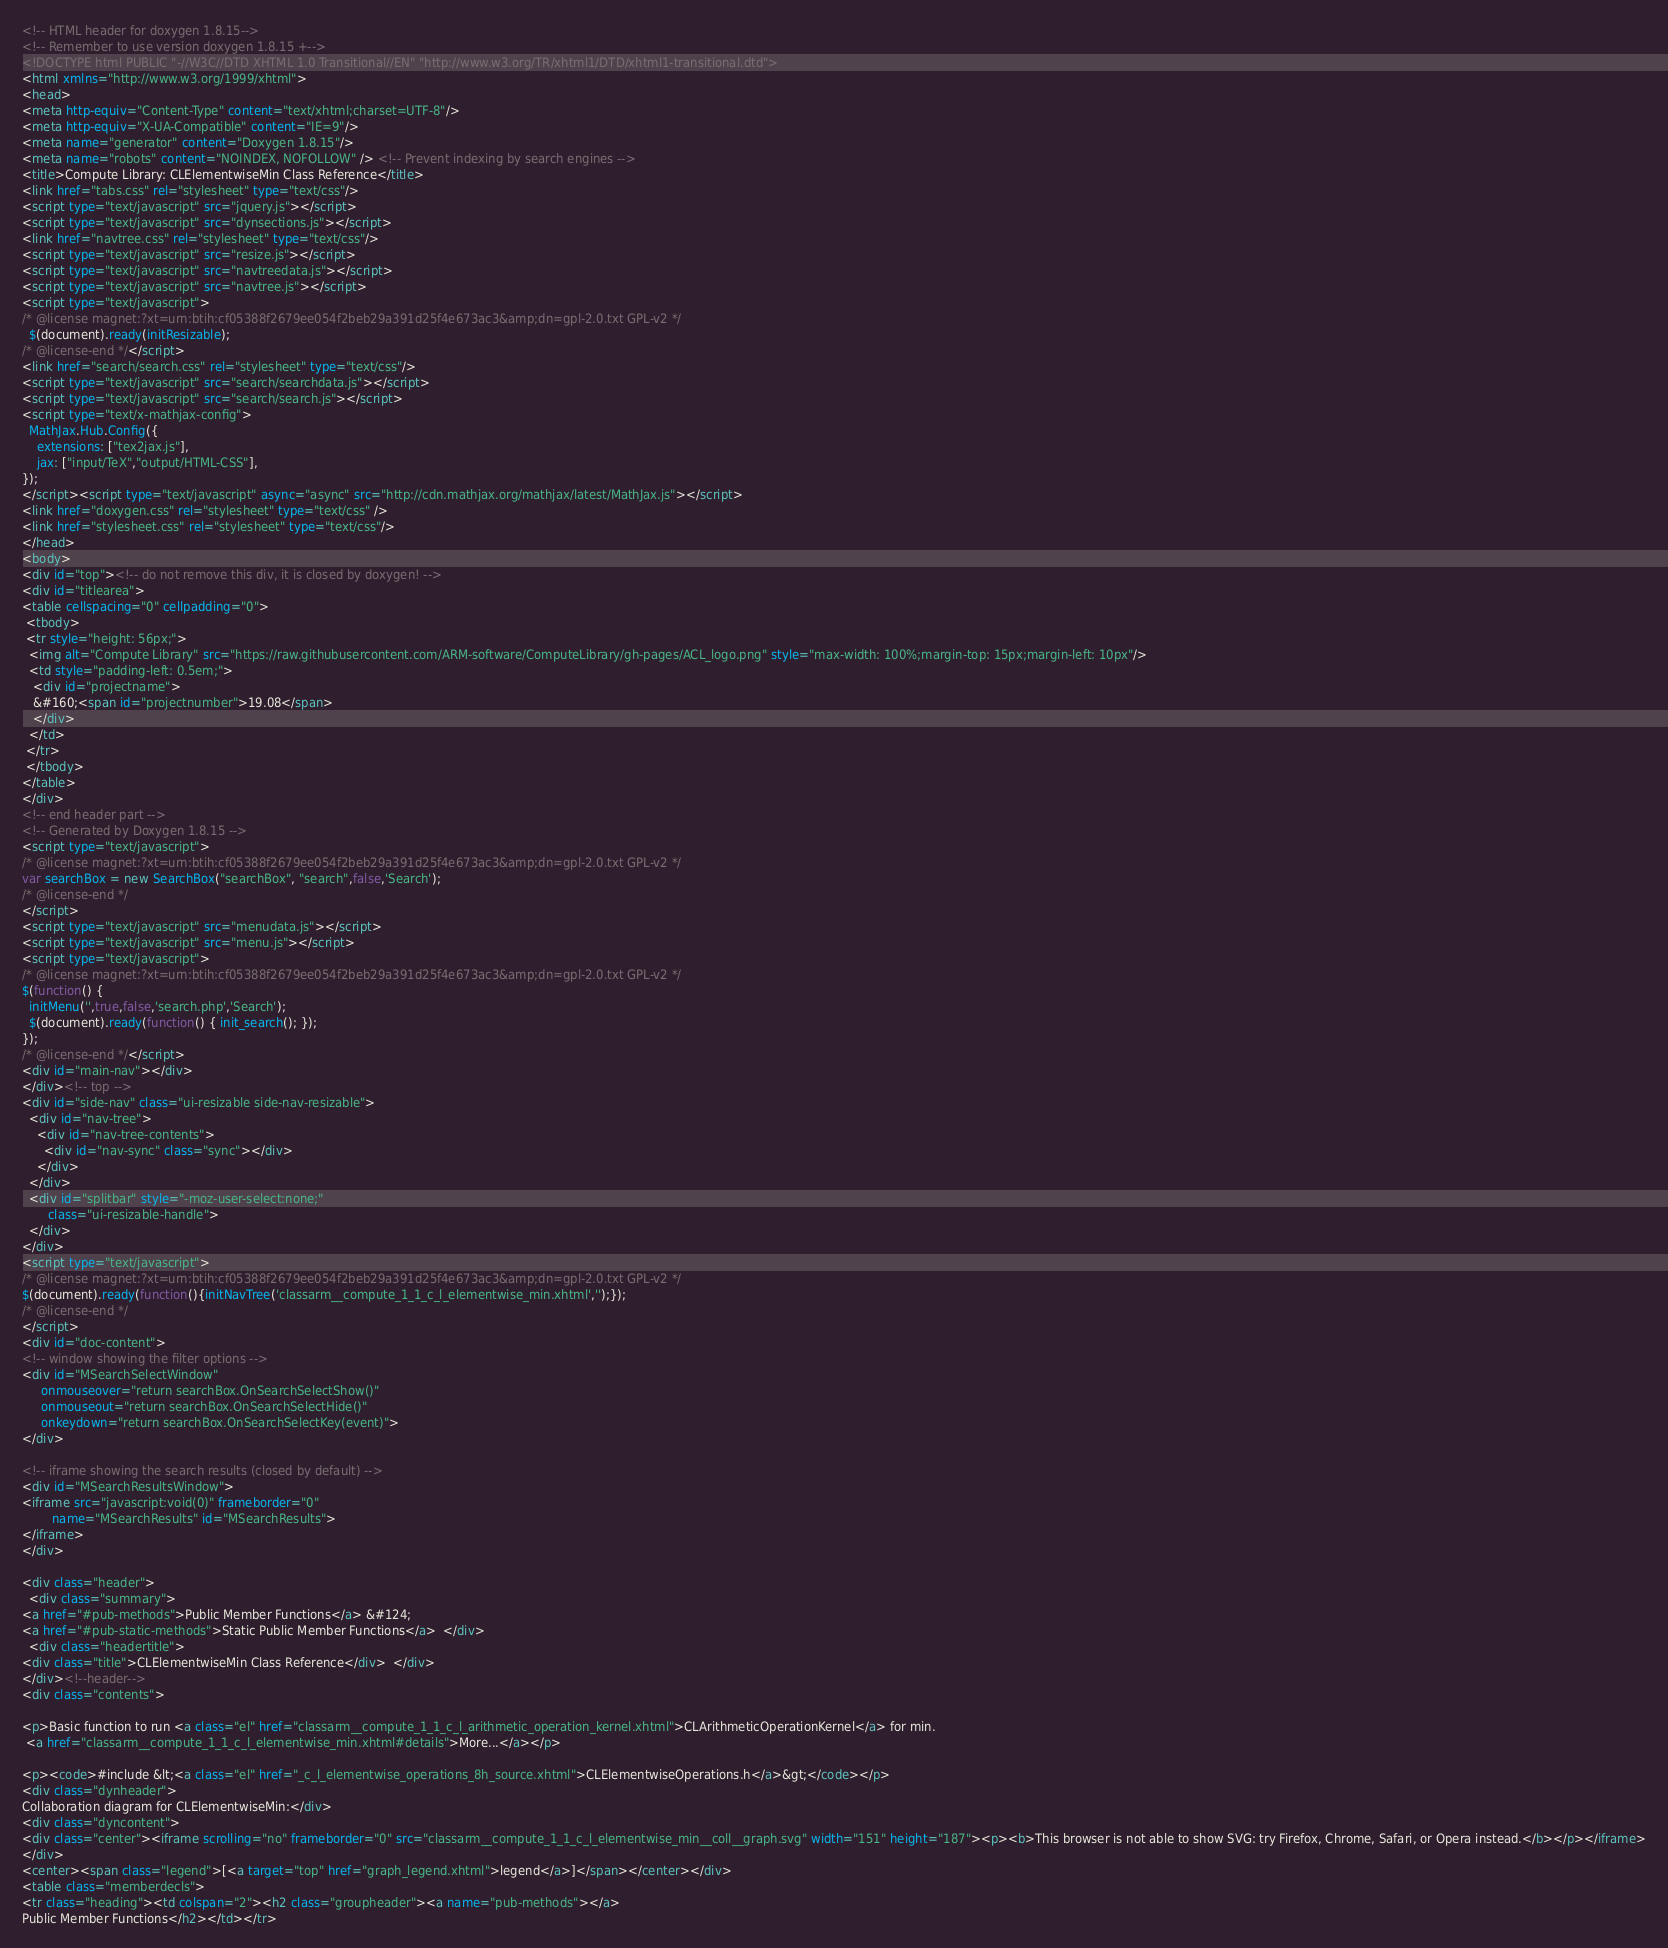Convert code to text. <code><loc_0><loc_0><loc_500><loc_500><_HTML_><!-- HTML header for doxygen 1.8.15-->
<!-- Remember to use version doxygen 1.8.15 +-->
<!DOCTYPE html PUBLIC "-//W3C//DTD XHTML 1.0 Transitional//EN" "http://www.w3.org/TR/xhtml1/DTD/xhtml1-transitional.dtd">
<html xmlns="http://www.w3.org/1999/xhtml">
<head>
<meta http-equiv="Content-Type" content="text/xhtml;charset=UTF-8"/>
<meta http-equiv="X-UA-Compatible" content="IE=9"/>
<meta name="generator" content="Doxygen 1.8.15"/>
<meta name="robots" content="NOINDEX, NOFOLLOW" /> <!-- Prevent indexing by search engines -->
<title>Compute Library: CLElementwiseMin Class Reference</title>
<link href="tabs.css" rel="stylesheet" type="text/css"/>
<script type="text/javascript" src="jquery.js"></script>
<script type="text/javascript" src="dynsections.js"></script>
<link href="navtree.css" rel="stylesheet" type="text/css"/>
<script type="text/javascript" src="resize.js"></script>
<script type="text/javascript" src="navtreedata.js"></script>
<script type="text/javascript" src="navtree.js"></script>
<script type="text/javascript">
/* @license magnet:?xt=urn:btih:cf05388f2679ee054f2beb29a391d25f4e673ac3&amp;dn=gpl-2.0.txt GPL-v2 */
  $(document).ready(initResizable);
/* @license-end */</script>
<link href="search/search.css" rel="stylesheet" type="text/css"/>
<script type="text/javascript" src="search/searchdata.js"></script>
<script type="text/javascript" src="search/search.js"></script>
<script type="text/x-mathjax-config">
  MathJax.Hub.Config({
    extensions: ["tex2jax.js"],
    jax: ["input/TeX","output/HTML-CSS"],
});
</script><script type="text/javascript" async="async" src="http://cdn.mathjax.org/mathjax/latest/MathJax.js"></script>
<link href="doxygen.css" rel="stylesheet" type="text/css" />
<link href="stylesheet.css" rel="stylesheet" type="text/css"/>
</head>
<body>
<div id="top"><!-- do not remove this div, it is closed by doxygen! -->
<div id="titlearea">
<table cellspacing="0" cellpadding="0">
 <tbody>
 <tr style="height: 56px;">
  <img alt="Compute Library" src="https://raw.githubusercontent.com/ARM-software/ComputeLibrary/gh-pages/ACL_logo.png" style="max-width: 100%;margin-top: 15px;margin-left: 10px"/>
  <td style="padding-left: 0.5em;">
   <div id="projectname">
   &#160;<span id="projectnumber">19.08</span>
   </div>
  </td>
 </tr>
 </tbody>
</table>
</div>
<!-- end header part -->
<!-- Generated by Doxygen 1.8.15 -->
<script type="text/javascript">
/* @license magnet:?xt=urn:btih:cf05388f2679ee054f2beb29a391d25f4e673ac3&amp;dn=gpl-2.0.txt GPL-v2 */
var searchBox = new SearchBox("searchBox", "search",false,'Search');
/* @license-end */
</script>
<script type="text/javascript" src="menudata.js"></script>
<script type="text/javascript" src="menu.js"></script>
<script type="text/javascript">
/* @license magnet:?xt=urn:btih:cf05388f2679ee054f2beb29a391d25f4e673ac3&amp;dn=gpl-2.0.txt GPL-v2 */
$(function() {
  initMenu('',true,false,'search.php','Search');
  $(document).ready(function() { init_search(); });
});
/* @license-end */</script>
<div id="main-nav"></div>
</div><!-- top -->
<div id="side-nav" class="ui-resizable side-nav-resizable">
  <div id="nav-tree">
    <div id="nav-tree-contents">
      <div id="nav-sync" class="sync"></div>
    </div>
  </div>
  <div id="splitbar" style="-moz-user-select:none;" 
       class="ui-resizable-handle">
  </div>
</div>
<script type="text/javascript">
/* @license magnet:?xt=urn:btih:cf05388f2679ee054f2beb29a391d25f4e673ac3&amp;dn=gpl-2.0.txt GPL-v2 */
$(document).ready(function(){initNavTree('classarm__compute_1_1_c_l_elementwise_min.xhtml','');});
/* @license-end */
</script>
<div id="doc-content">
<!-- window showing the filter options -->
<div id="MSearchSelectWindow"
     onmouseover="return searchBox.OnSearchSelectShow()"
     onmouseout="return searchBox.OnSearchSelectHide()"
     onkeydown="return searchBox.OnSearchSelectKey(event)">
</div>

<!-- iframe showing the search results (closed by default) -->
<div id="MSearchResultsWindow">
<iframe src="javascript:void(0)" frameborder="0" 
        name="MSearchResults" id="MSearchResults">
</iframe>
</div>

<div class="header">
  <div class="summary">
<a href="#pub-methods">Public Member Functions</a> &#124;
<a href="#pub-static-methods">Static Public Member Functions</a>  </div>
  <div class="headertitle">
<div class="title">CLElementwiseMin Class Reference</div>  </div>
</div><!--header-->
<div class="contents">

<p>Basic function to run <a class="el" href="classarm__compute_1_1_c_l_arithmetic_operation_kernel.xhtml">CLArithmeticOperationKernel</a> for min.  
 <a href="classarm__compute_1_1_c_l_elementwise_min.xhtml#details">More...</a></p>

<p><code>#include &lt;<a class="el" href="_c_l_elementwise_operations_8h_source.xhtml">CLElementwiseOperations.h</a>&gt;</code></p>
<div class="dynheader">
Collaboration diagram for CLElementwiseMin:</div>
<div class="dyncontent">
<div class="center"><iframe scrolling="no" frameborder="0" src="classarm__compute_1_1_c_l_elementwise_min__coll__graph.svg" width="151" height="187"><p><b>This browser is not able to show SVG: try Firefox, Chrome, Safari, or Opera instead.</b></p></iframe>
</div>
<center><span class="legend">[<a target="top" href="graph_legend.xhtml">legend</a>]</span></center></div>
<table class="memberdecls">
<tr class="heading"><td colspan="2"><h2 class="groupheader"><a name="pub-methods"></a>
Public Member Functions</h2></td></tr></code> 